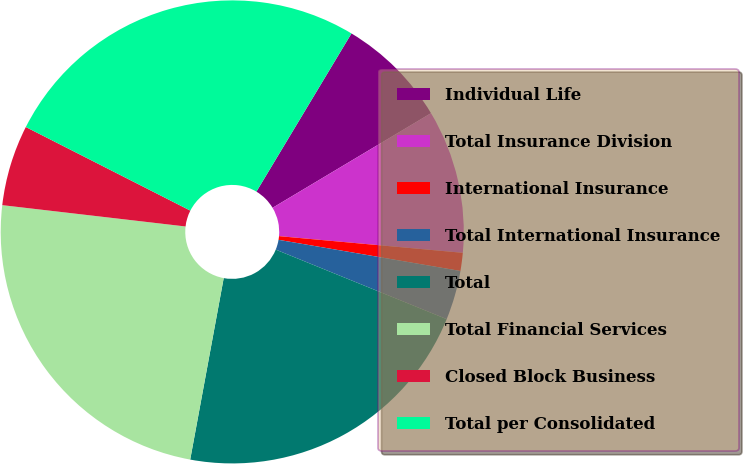<chart> <loc_0><loc_0><loc_500><loc_500><pie_chart><fcel>Individual Life<fcel>Total Insurance Division<fcel>International Insurance<fcel>Total International Insurance<fcel>Total<fcel>Total Financial Services<fcel>Closed Block Business<fcel>Total per Consolidated<nl><fcel>7.82%<fcel>10.01%<fcel>1.26%<fcel>3.45%<fcel>21.76%<fcel>23.94%<fcel>5.64%<fcel>26.13%<nl></chart> 